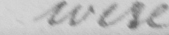Please provide the text content of this handwritten line. were 